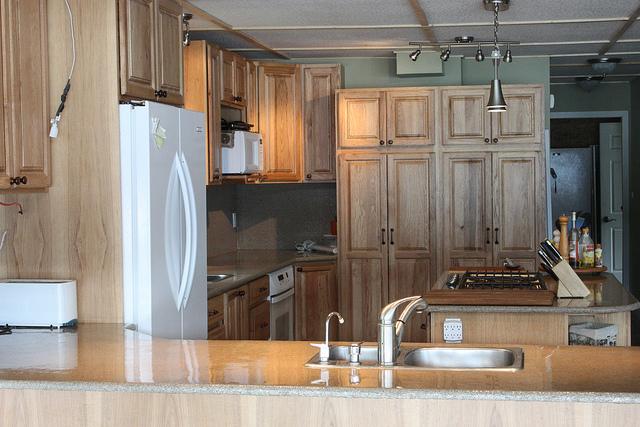Does this kitchen have cabinetry?
Short answer required. Yes. Are there any stainless steel kitchen appliances?
Write a very short answer. No. Where is the stove top located?
Be succinct. Island. 